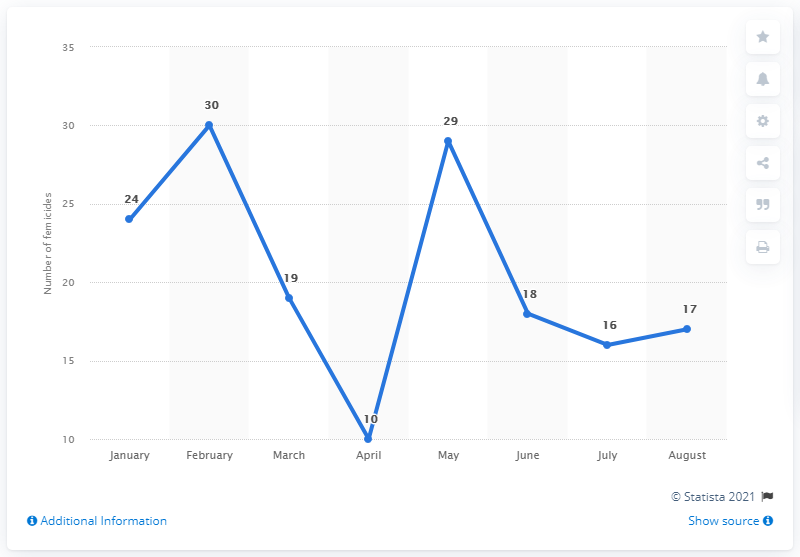Specify some key components in this picture. March was the month with the highest number of femicide victims. The average is 163. February is the month that experiences the highest number of femicides. 